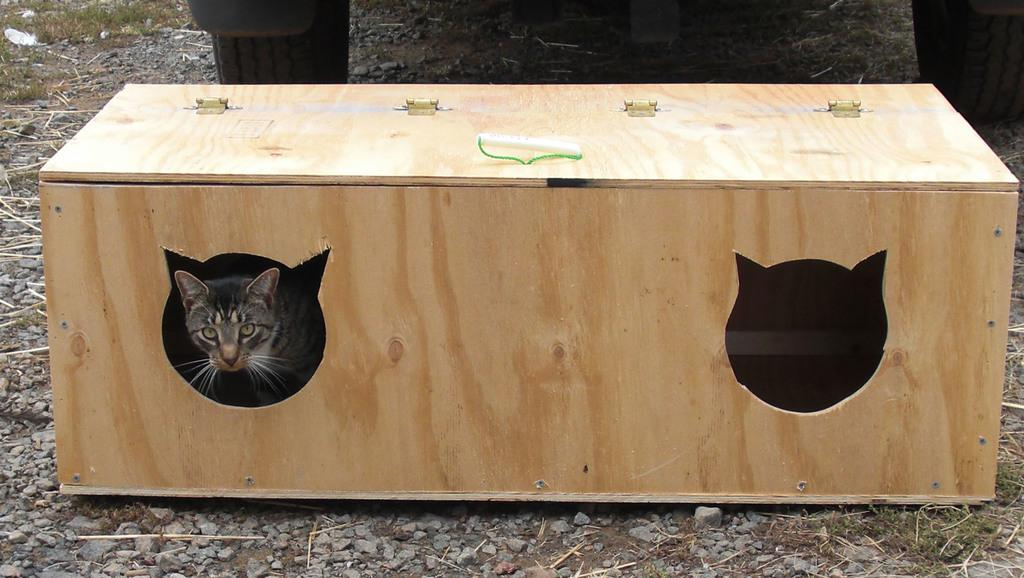What object is made of wood in the image? There is a wooden box in the image. What is inside the wooden box? A cat is inside the wooden box. What type of natural material can be seen in the image? Stones are visible in the image. What parts of a vehicle are present in the image? Two tires of a vehicle are present in the image. What type of vegetation is visible in the image? Grass is visible in the image. Where is the monkey sitting in the image? There is no monkey present in the image. What type of base is supporting the wooden box in the image? The wooden box is not shown to be resting on any base in the image. 